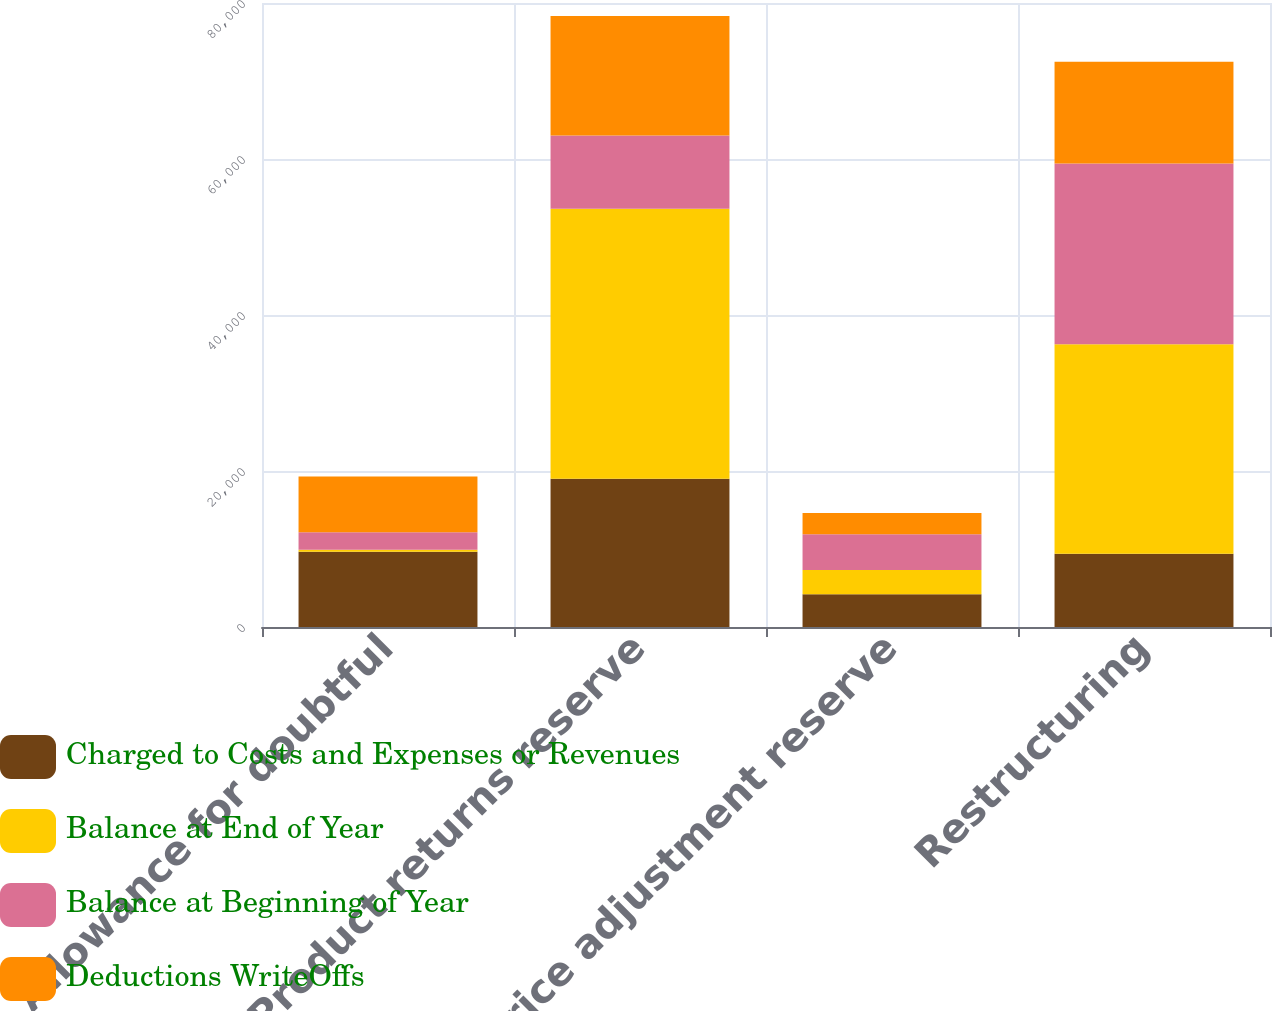<chart> <loc_0><loc_0><loc_500><loc_500><stacked_bar_chart><ecel><fcel>Allowance for doubtful<fcel>Product returns reserve<fcel>Price adjustment reserve<fcel>Restructuring<nl><fcel>Charged to Costs and Expenses or Revenues<fcel>9654<fcel>19017<fcel>4191<fcel>9403<nl><fcel>Balance at End of Year<fcel>236<fcel>34598<fcel>3110<fcel>26837<nl><fcel>Balance at Beginning of Year<fcel>2265<fcel>9403<fcel>4599<fcel>23169<nl><fcel>Deductions WriteOffs<fcel>7153<fcel>15311<fcel>2702<fcel>13071<nl></chart> 